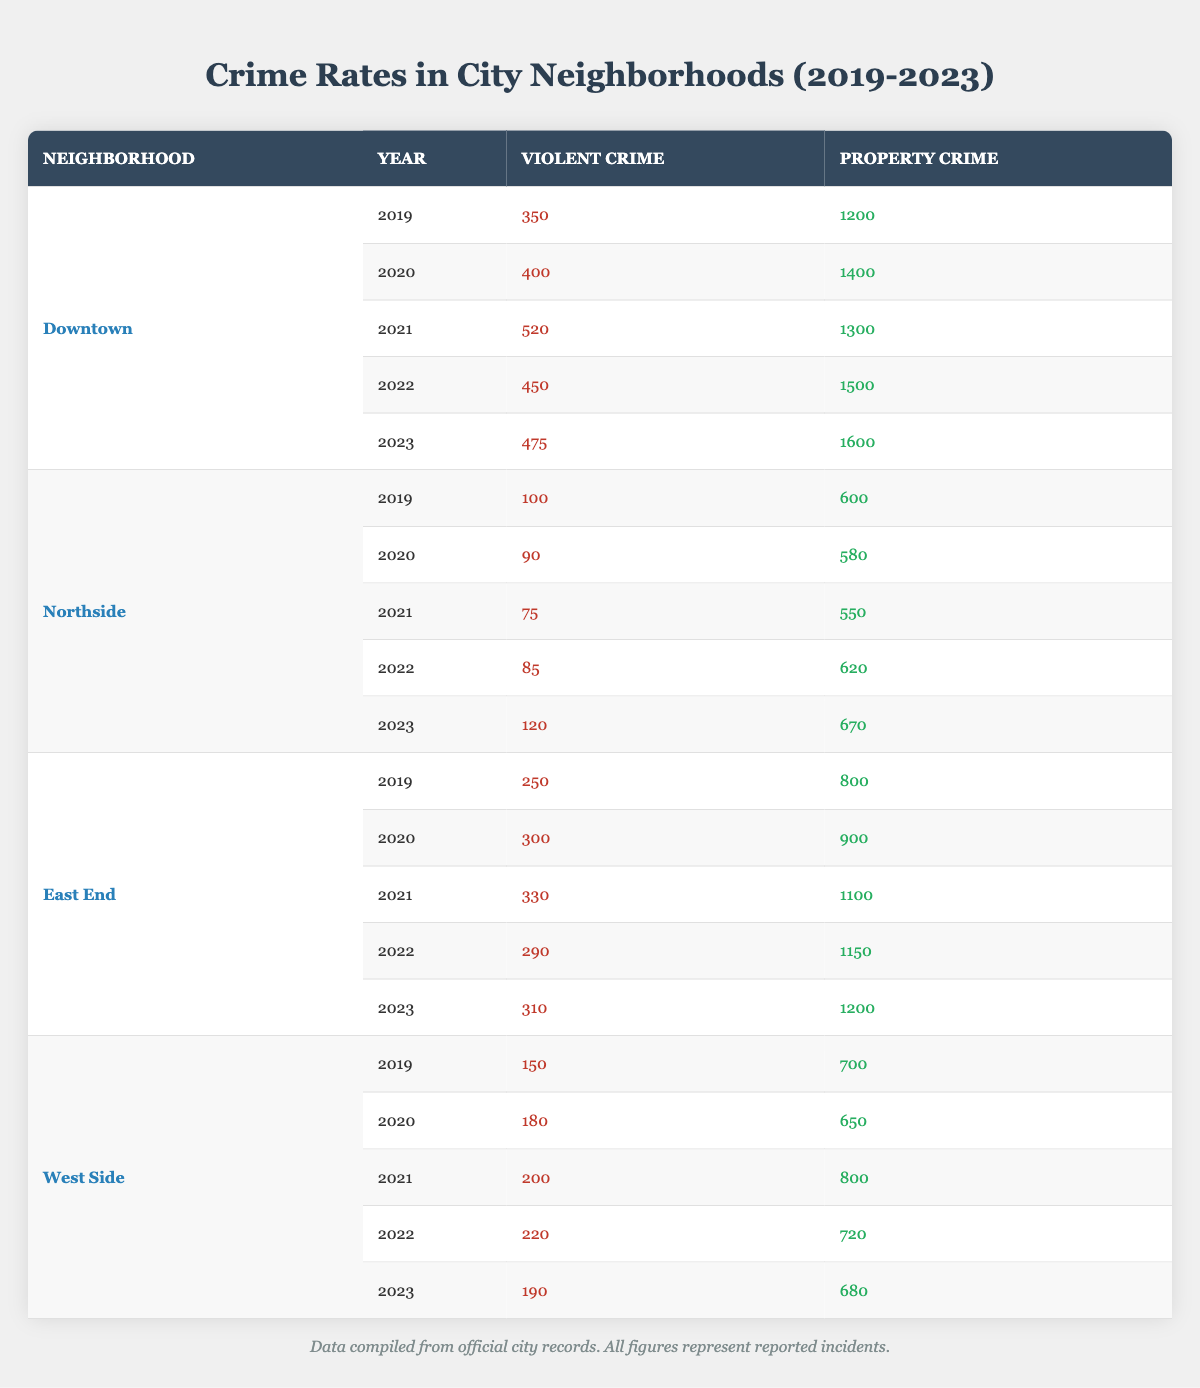What was the violent crime count in Downtown for the year 2021? According to the table, the violent crime count in Downtown for the year 2021 is listed directly under the violent crime column for that year. It shows 520 incidents.
Answer: 520 What is the total number of property crimes reported in East End from 2019 to 2023? To find the total property crimes in East End from 2019 to 2023, sum the property crime values: 800 + 900 + 1100 + 1150 + 1200 = 4150.
Answer: 4150 Did the violent crime rate in Northside increase from 2019 to 2023? In 2019, violent crime was 100, and in 2023, it was 120. Since 120 is greater than 100, we can conclude that there was an increase.
Answer: Yes What was the difference in violent crime between West Side and Downtown in 2022? In 2022, West Side had 220 violent crimes, while Downtown had 450. The difference is calculated by subtracting the two values: 450 - 220 = 230.
Answer: 230 Which neighborhood had the highest property crime in 2023 and what was the figure? Looking at the property crime data for 2023, Downtown had 1600 incidents, which is higher than Northside (670), East End (1200), and West Side (680). Therefore, Downtown is the neighborhood with the highest property crime in 2023.
Answer: Downtown, 1600 